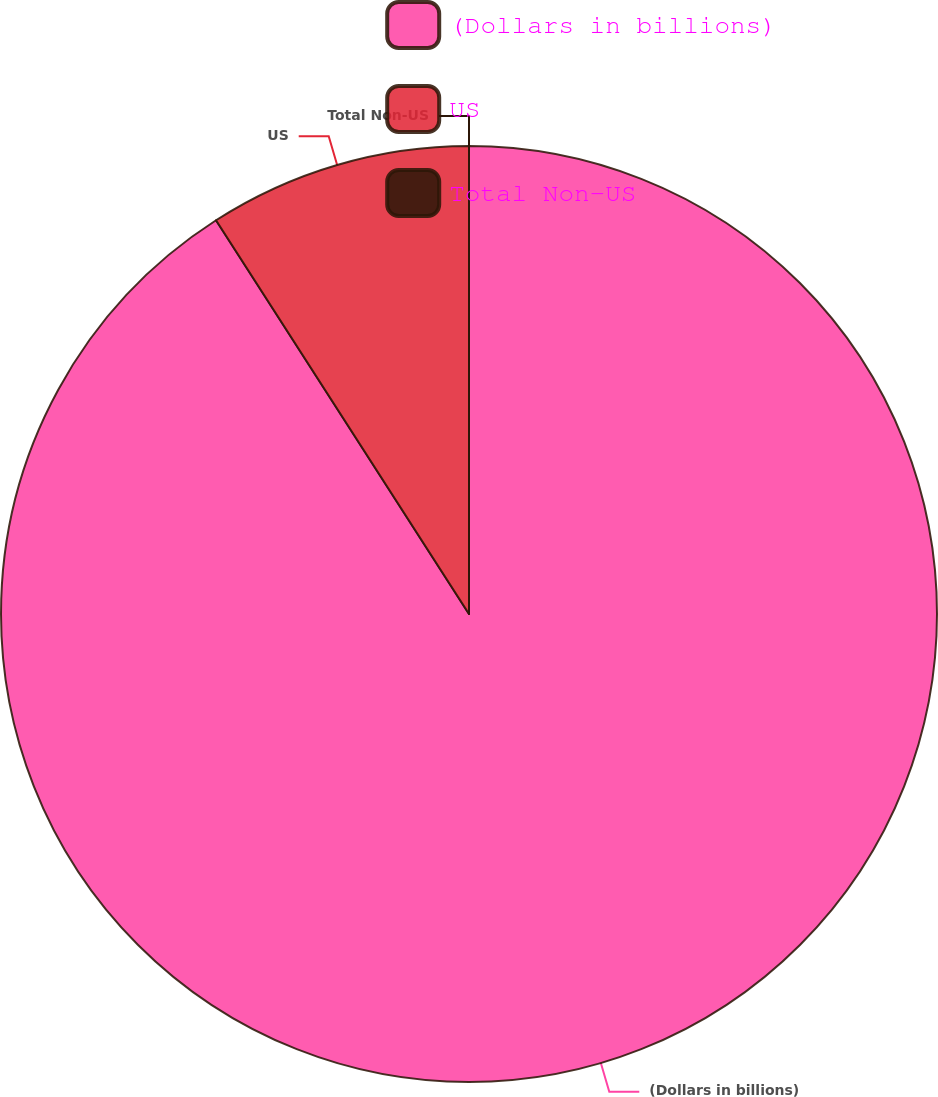Convert chart. <chart><loc_0><loc_0><loc_500><loc_500><pie_chart><fcel>(Dollars in billions)<fcel>US<fcel>Total Non-US<nl><fcel>90.91%<fcel>9.09%<fcel>0.0%<nl></chart> 